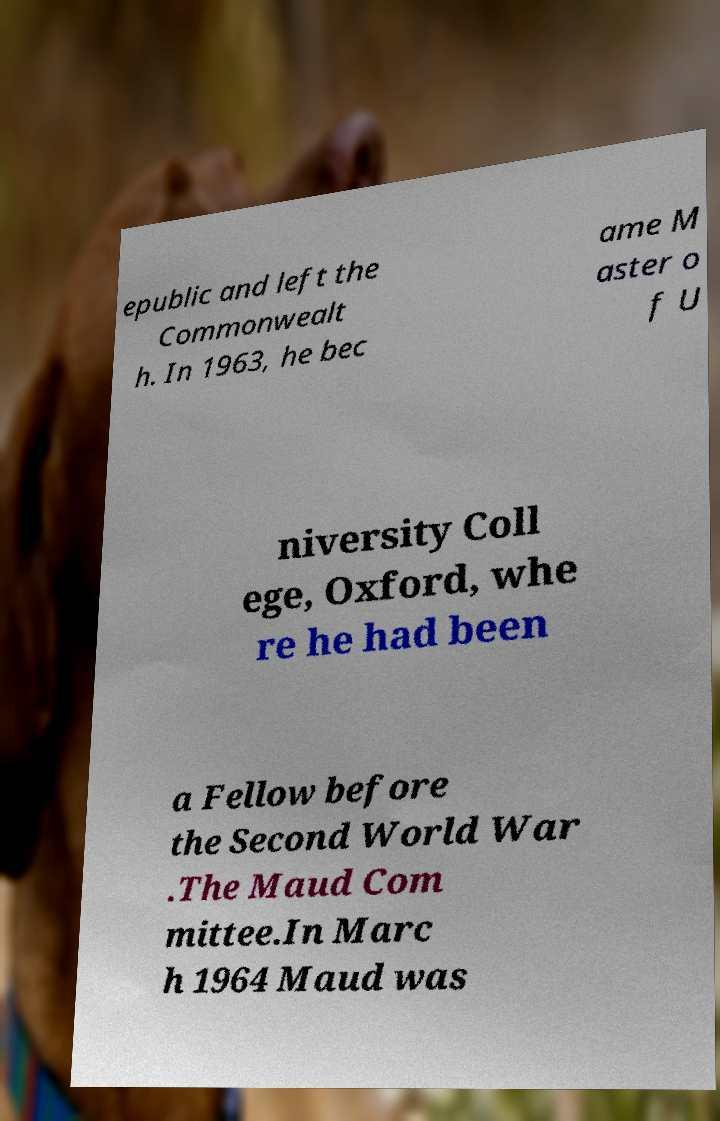Can you read and provide the text displayed in the image?This photo seems to have some interesting text. Can you extract and type it out for me? epublic and left the Commonwealt h. In 1963, he bec ame M aster o f U niversity Coll ege, Oxford, whe re he had been a Fellow before the Second World War .The Maud Com mittee.In Marc h 1964 Maud was 